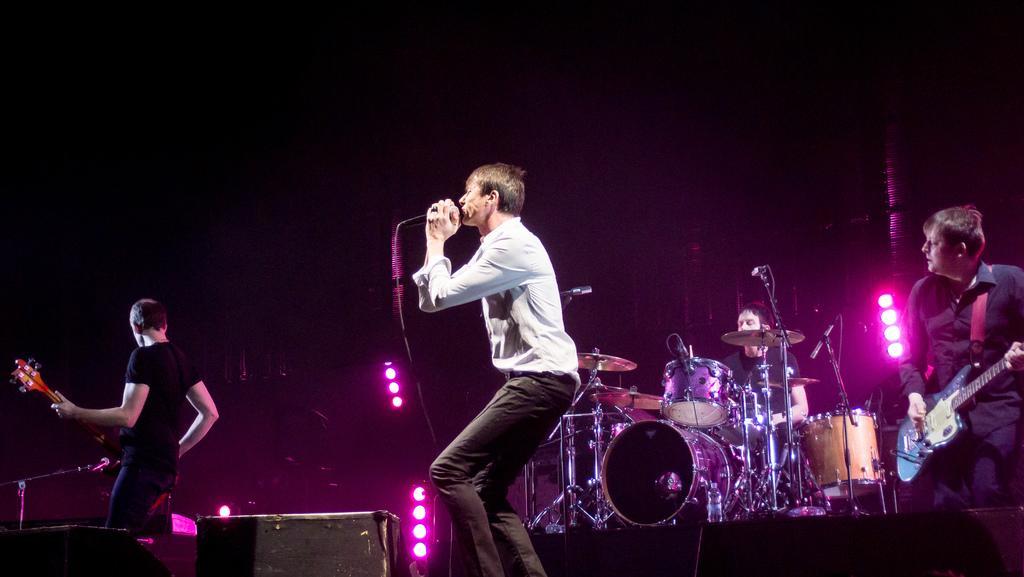In one or two sentences, can you explain what this image depicts? Front this man wore white shirt and singing in-front of mic. Far these three persons are playing musical instruments. At background there are focusing lights. 